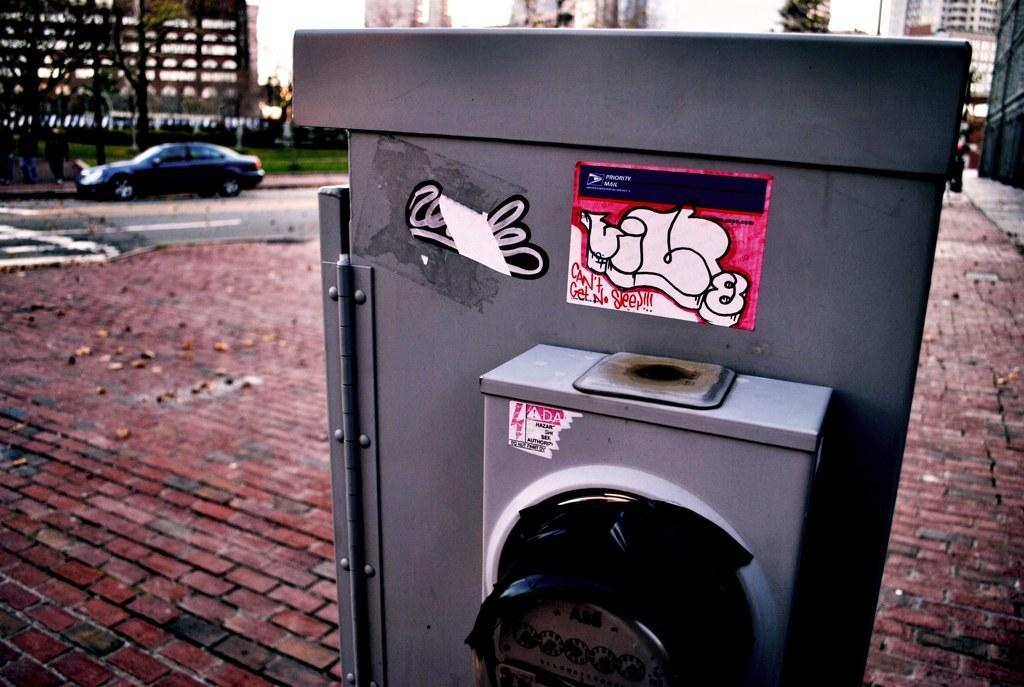<image>
Relay a brief, clear account of the picture shown. A meter that has several stickers on it some that are partially ripped off. 